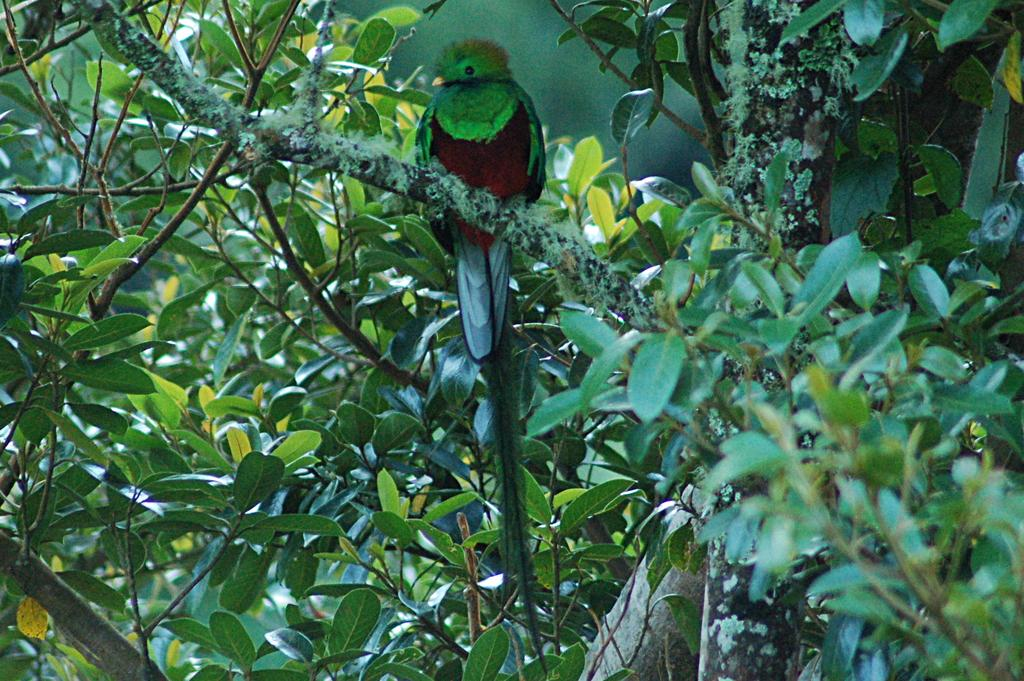What type of vegetation can be seen in the image? There are trees in the image. What animal is present in the image? There is a quetzal bird in the image. Where is the quetzal bird located in the image? The quetzal bird is on a tree branch. What type of teeth does the quetzal bird have in the image? The image does not show the quetzal bird's teeth, as birds do not have teeth. 